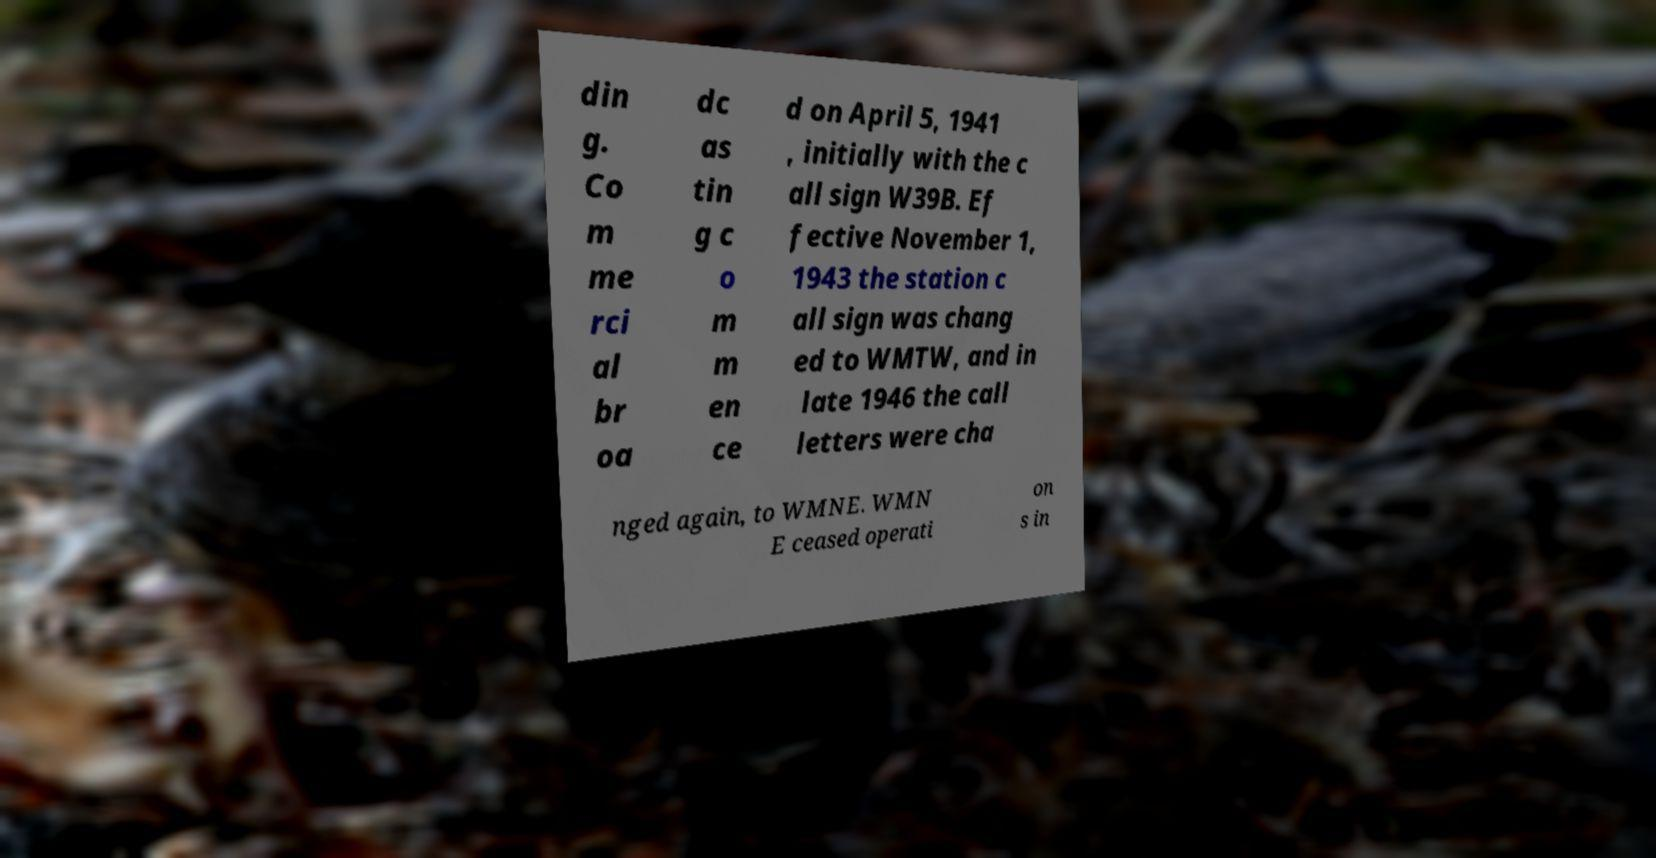There's text embedded in this image that I need extracted. Can you transcribe it verbatim? din g. Co m me rci al br oa dc as tin g c o m m en ce d on April 5, 1941 , initially with the c all sign W39B. Ef fective November 1, 1943 the station c all sign was chang ed to WMTW, and in late 1946 the call letters were cha nged again, to WMNE. WMN E ceased operati on s in 